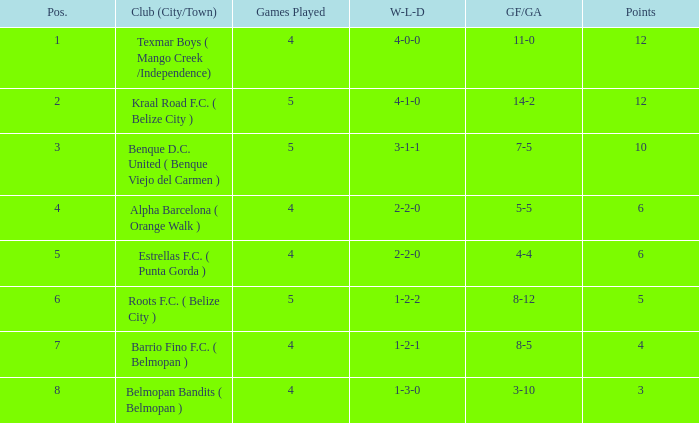Who is the the club (city/town) with goals for/against being 14-2 Kraal Road F.C. ( Belize City ). 